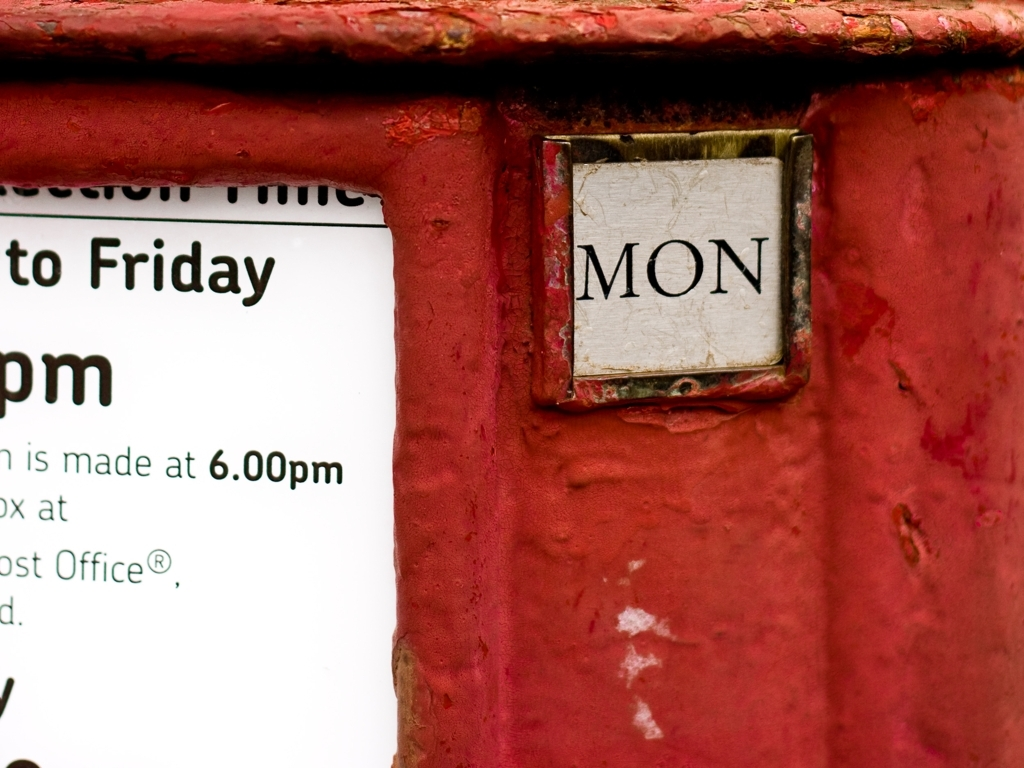What does the 'MON' plaque on the image suggest? The 'MON' plaque suggests that this post box has a feature to indicate the current day of the week - in this case, Monday. It is likely that this plaque can be changed daily to reflect the correct day, which is part of a system to inform the public about the next collection day. 